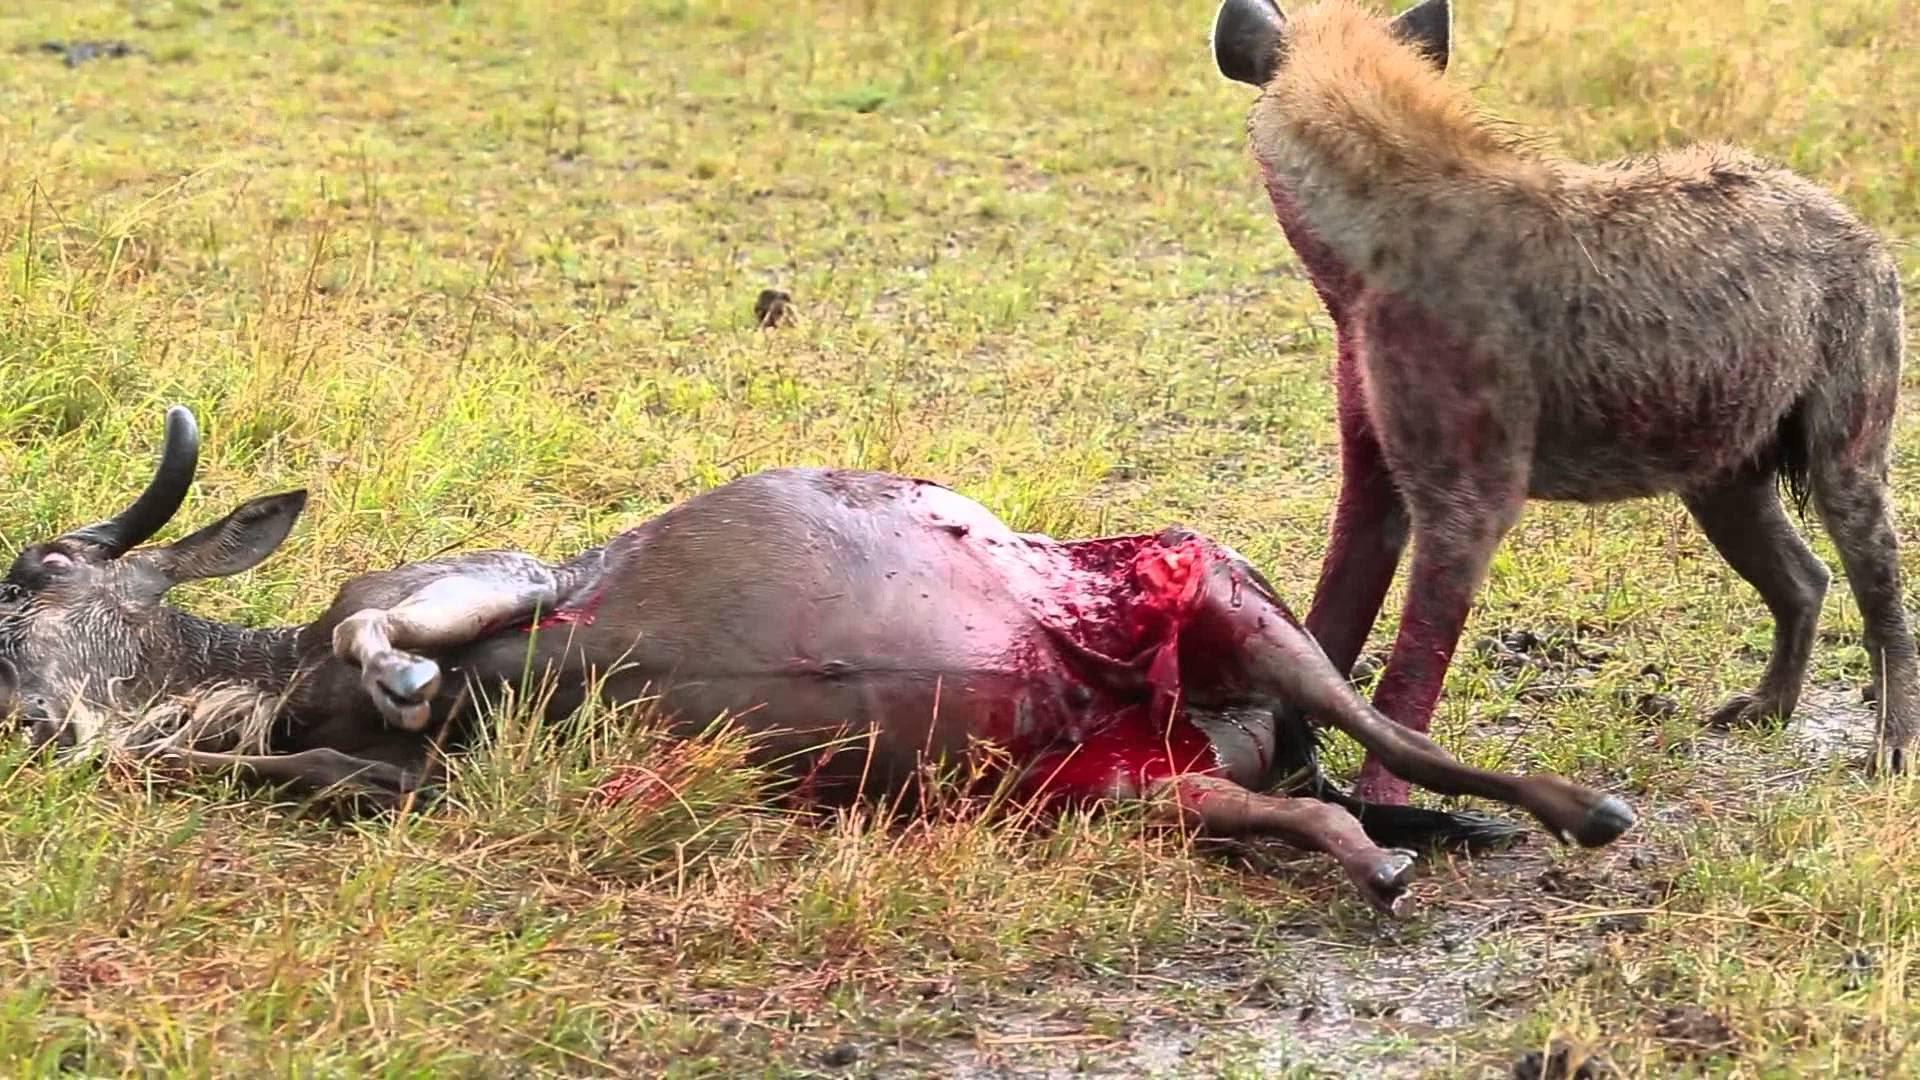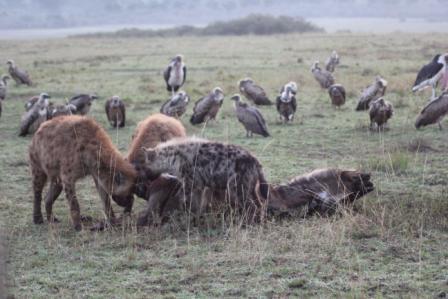The first image is the image on the left, the second image is the image on the right. Examine the images to the left and right. Is the description "The right image contains no more than two hyenas." accurate? Answer yes or no. No. The first image is the image on the left, the second image is the image on the right. Analyze the images presented: Is the assertion "The left image shows one hyena facing away from the camera and standing next to a downed horned animal that is larger than the hyena." valid? Answer yes or no. Yes. 